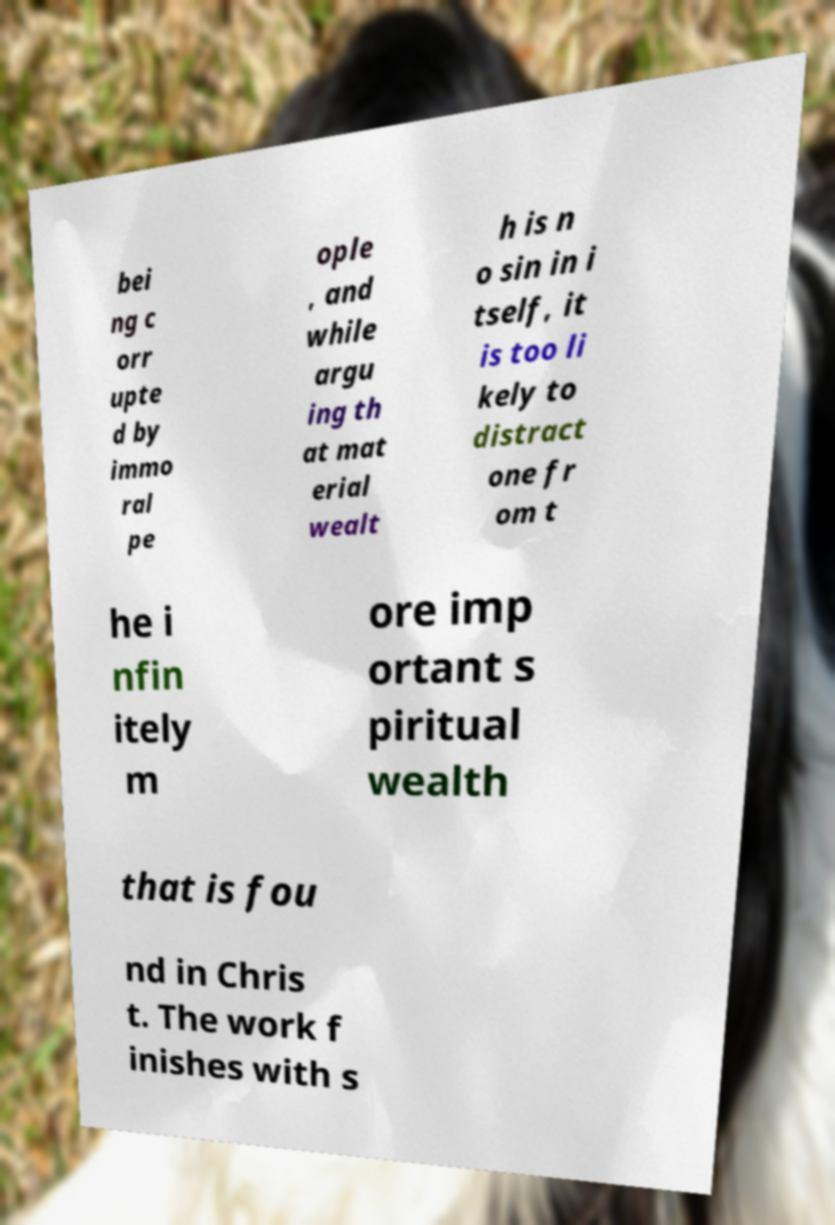What messages or text are displayed in this image? I need them in a readable, typed format. bei ng c orr upte d by immo ral pe ople , and while argu ing th at mat erial wealt h is n o sin in i tself, it is too li kely to distract one fr om t he i nfin itely m ore imp ortant s piritual wealth that is fou nd in Chris t. The work f inishes with s 